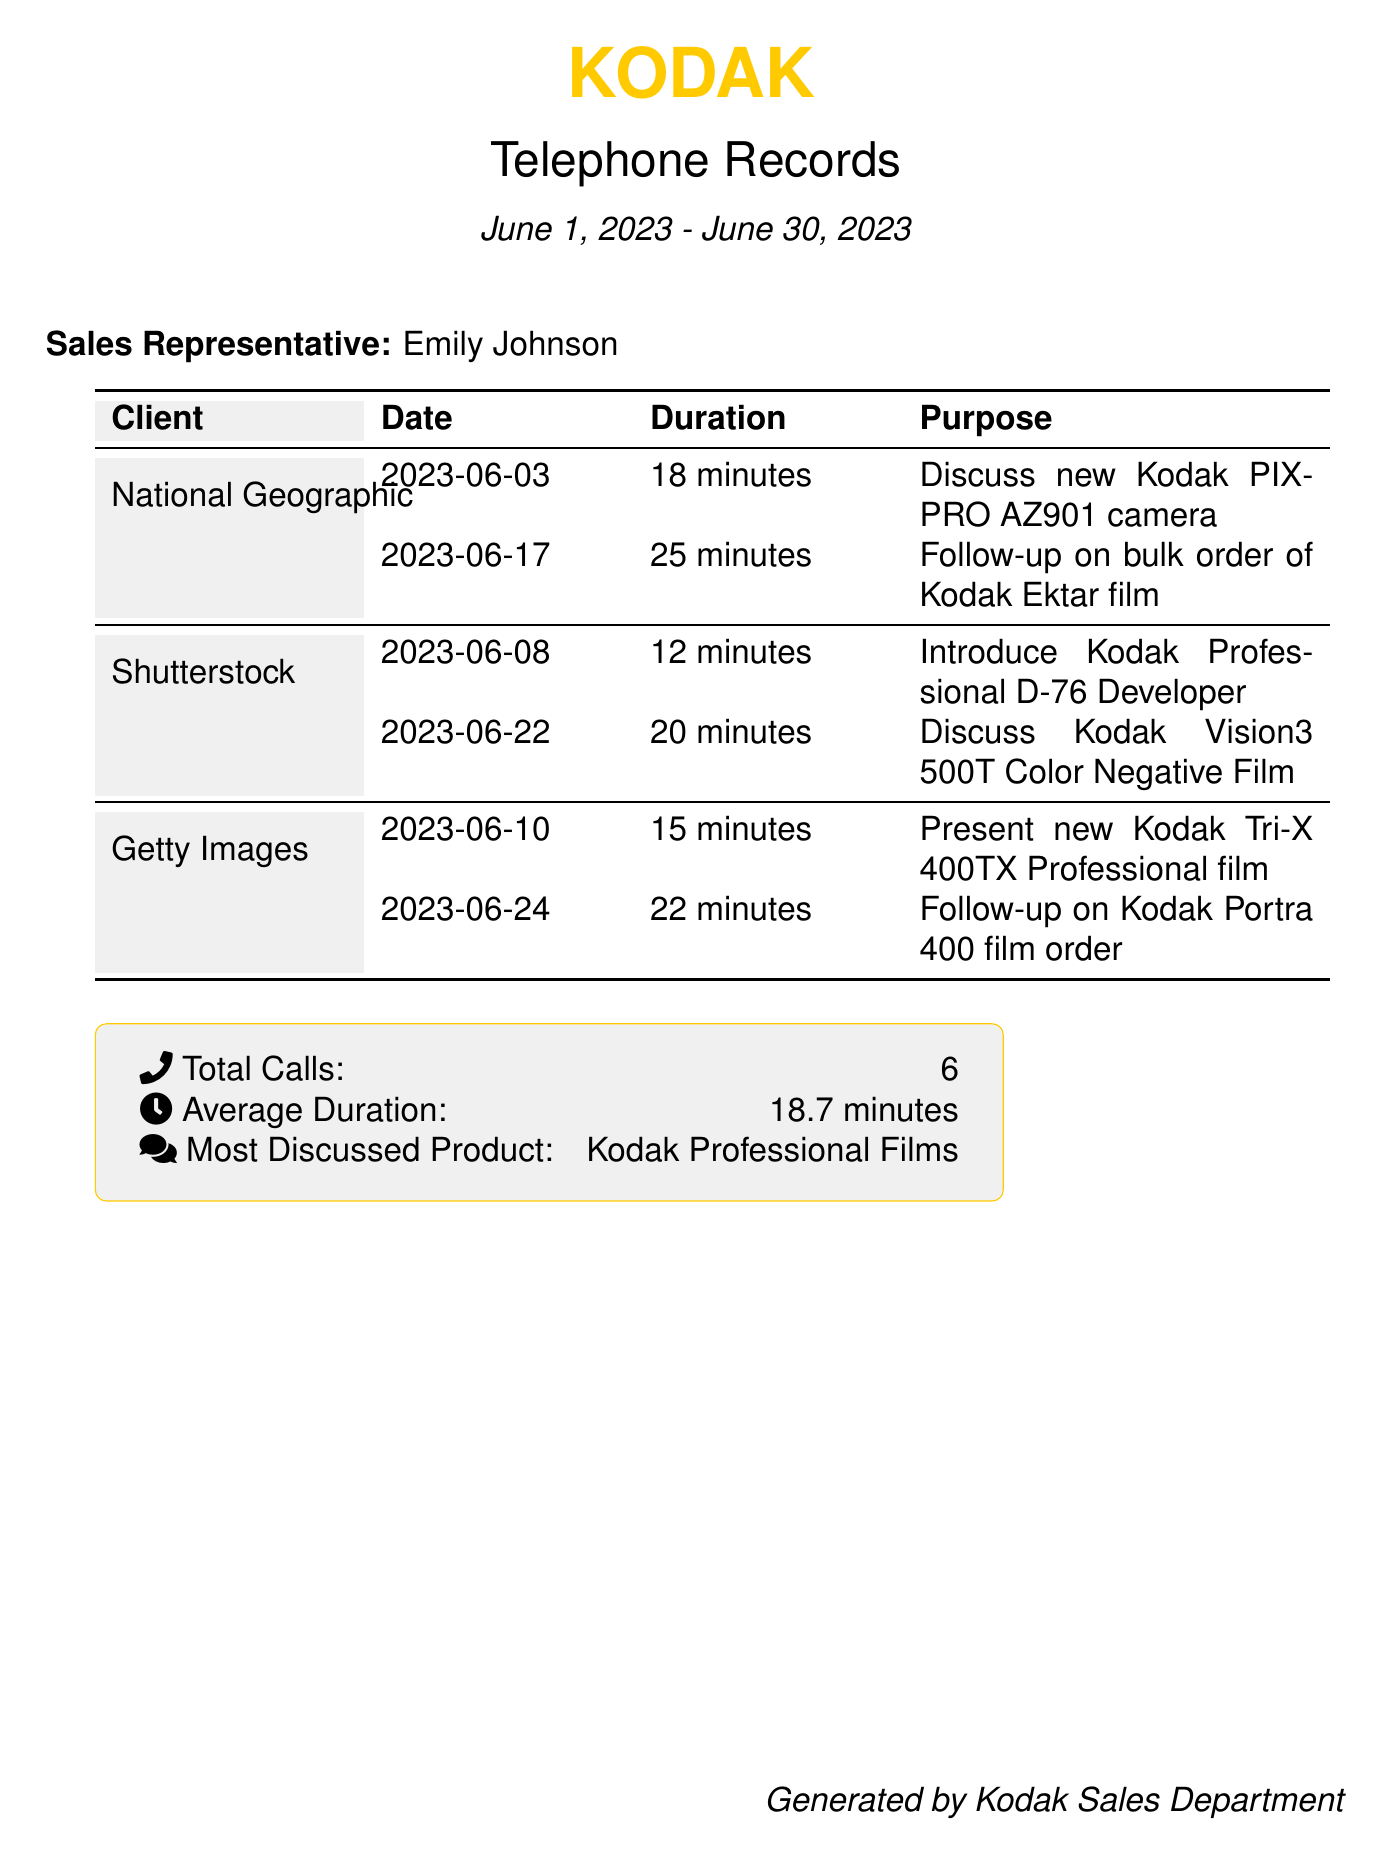What is the document title? The document title is prominently displayed at the top and indicates the content related to telephone records.
Answer: Telephone Records Who is the sales representative? The sales representative's name is stated in the document as part of the introductory section.
Answer: Emily Johnson What is the total number of calls made? The total number of calls is summarized in the statistics section at the bottom of the document.
Answer: 6 What is the average duration of the calls? The average duration is provided in the statistics section and calculated based on the recorded call durations.
Answer: 18.7 minutes Which client had the longest call duration? The longest call duration needs to be determined by examining the call durations listed for each client.
Answer: 25 minutes (National Geographic) What products were most discussed? The most discussed products are noted in the summary section that highlights the sales focus of the calls.
Answer: Kodak Professional Films How many calls were made to National Geographic? The total calls to National Geographic are indicated by the number of entries listed under that client in the document.
Answer: 2 What date was the follow-up on the bulk order of Kodak Ektar film? The date for the follow-up is explicitly stated in the client call records section of the document.
Answer: 2023-06-17 What is the purpose of the call on June 10th? The purpose of the call on a specific date is mentioned in the associated records for Getty Images in the document.
Answer: Present new Kodak Tri-X 400TX Professional film 